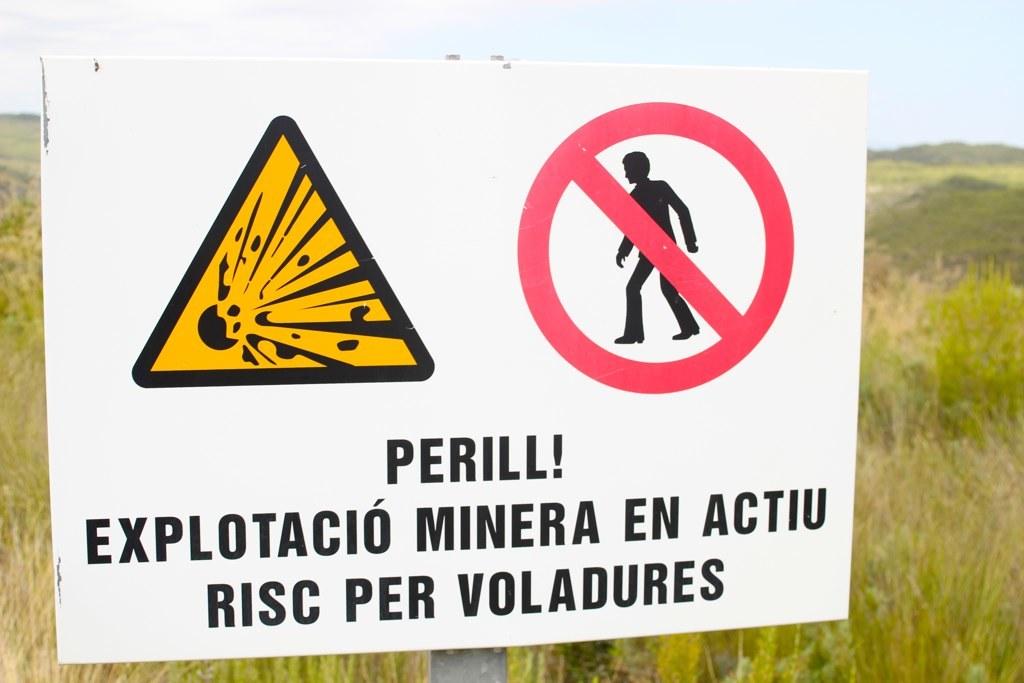What language is this warning written in?
Your answer should be compact. Unanswerable. 